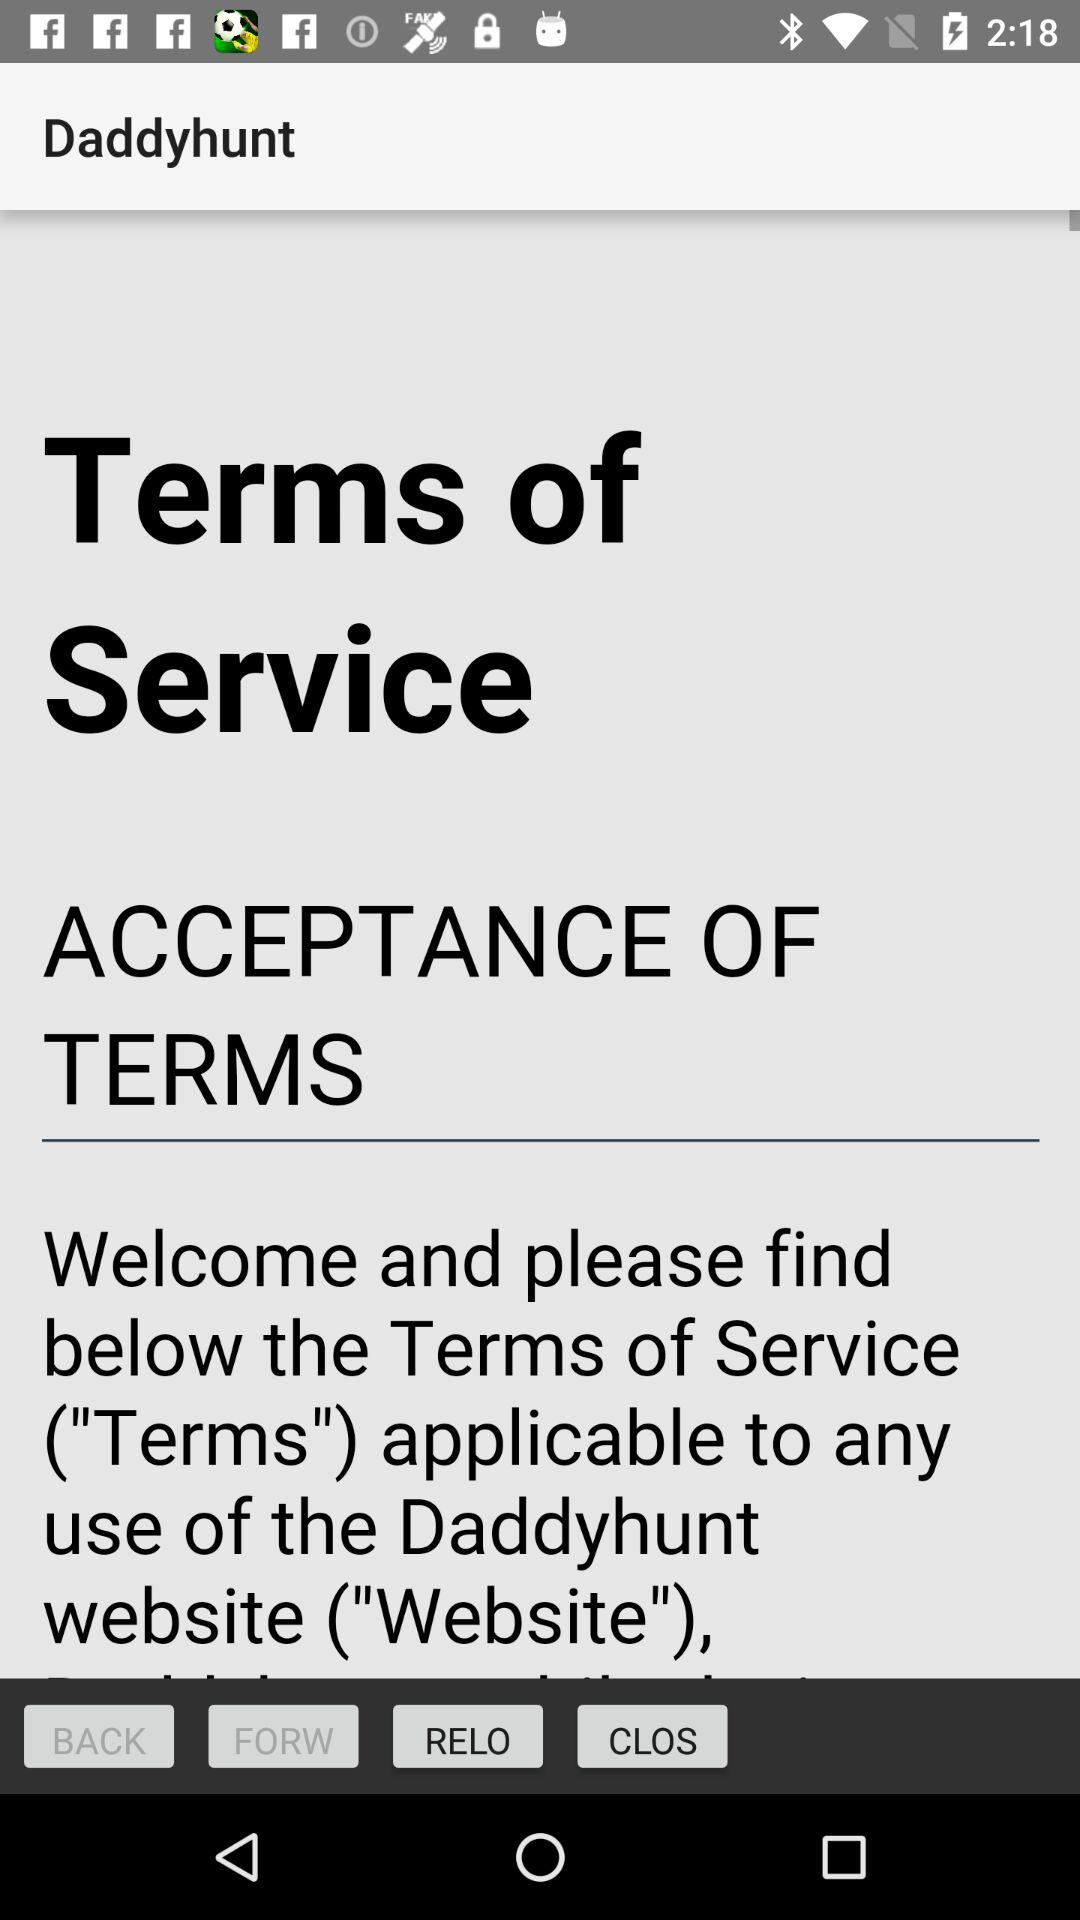What is the name of the application? The name of the application is "Daddyhunt". 